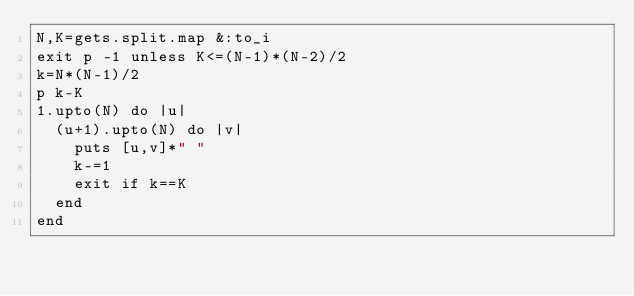Convert code to text. <code><loc_0><loc_0><loc_500><loc_500><_Ruby_>N,K=gets.split.map &:to_i
exit p -1 unless K<=(N-1)*(N-2)/2
k=N*(N-1)/2
p k-K
1.upto(N) do |u|
  (u+1).upto(N) do |v|
    puts [u,v]*" "
    k-=1
    exit if k==K
  end
end</code> 